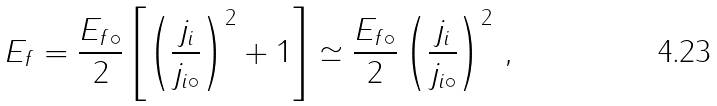Convert formula to latex. <formula><loc_0><loc_0><loc_500><loc_500>{ E _ { f } } = \frac { { E _ { f \circ } } } { 2 } \left [ \left ( \frac { { j _ { \| i } } } { { j _ { \| i \circ } } } \right ) ^ { 2 } + 1 \right ] \simeq \frac { { E _ { f \circ } } } { 2 } \left ( \frac { { j _ { \| i } } } { { j _ { \| i \circ } } } \right ) ^ { 2 } \, ,</formula> 